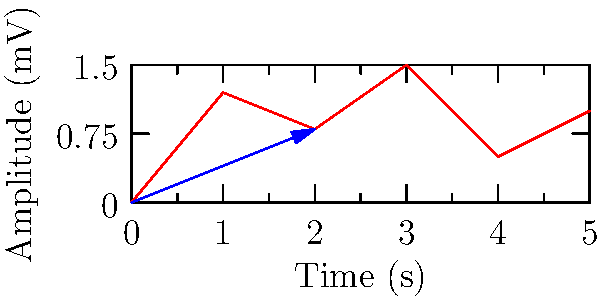An ECG signal is recorded with a peak at $(2, 0.8)$ in rectangular coordinates. Convert this point to polar coordinates $(r, \theta)$. Round $r$ to two decimal places and $\theta$ to the nearest degree. To convert from rectangular coordinates $(x, y)$ to polar coordinates $(r, \theta)$, we use the following formulas:

1. $r = \sqrt{x^2 + y^2}$
2. $\theta = \tan^{-1}(\frac{y}{x})$

For the given point $(2, 0.8)$:

1. Calculate $r$:
   $r = \sqrt{2^2 + 0.8^2}$
   $r = \sqrt{4 + 0.64}$
   $r = \sqrt{4.64}$
   $r \approx 2.15$ (rounded to two decimal places)

2. Calculate $\theta$:
   $\theta = \tan^{-1}(\frac{0.8}{2})$
   $\theta = \tan^{-1}(0.4)$
   $\theta \approx 21.80^\circ$
   $\theta \approx 22^\circ$ (rounded to the nearest degree)

Therefore, the point $(2, 0.8)$ in rectangular coordinates is approximately $(2.15, 22^\circ)$ in polar coordinates.
Answer: $(2.15, 22^\circ)$ 